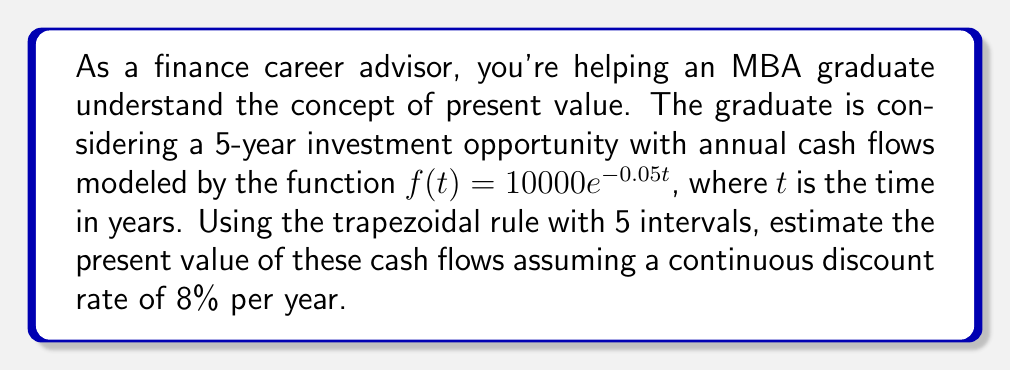Provide a solution to this math problem. Let's approach this step-by-step:

1) The present value of a continuous cash flow stream is given by the integral:

   $$PV = \int_0^T e^{-rt}f(t)dt$$

   where $r$ is the discount rate and $T$ is the time horizon.

2) In this case, $r = 0.08$, $T = 5$, and $f(t) = 10000e^{-0.05t}$

3) Our integral becomes:

   $$PV = \int_0^5 e^{-0.08t}(10000e^{-0.05t})dt = 10000\int_0^5 e^{-0.13t}dt$$

4) To apply the trapezoidal rule with 5 intervals, we need to divide the interval [0,5] into 5 equal parts. Each subinterval will have a width of $h = \frac{5-0}{5} = 1$

5) The trapezoidal rule formula is:

   $$\int_a^b f(x)dx \approx \frac{h}{2}[f(x_0) + 2f(x_1) + 2f(x_2) + ... + 2f(x_{n-1}) + f(x_n)]$$

6) We need to evaluate $10000e^{-0.13t}$ at $t = 0, 1, 2, 3, 4, 5$:

   $t = 0: 10000e^{-0.13(0)} = 10000$
   $t = 1: 10000e^{-0.13(1)} = 8781.14$
   $t = 2: 10000e^{-0.13(2)} = 7711.49$
   $t = 3: 10000e^{-0.13(3)} = 6772.86$
   $t = 4: 10000e^{-0.13(4)} = 5946.08$
   $t = 5: 10000e^{-0.13(5)} = 5220.81$

7) Applying the trapezoidal rule:

   $$PV \approx \frac{1}{2}[10000 + 2(8781.14 + 7711.49 + 6772.86 + 5946.08) + 5220.81]$$

8) Calculating:

   $$PV \approx \frac{1}{2}[10000 + 58423.14 + 5220.81] = 36821.98$$

Therefore, the estimated present value is approximately $36,821.98.
Answer: $36,821.98 